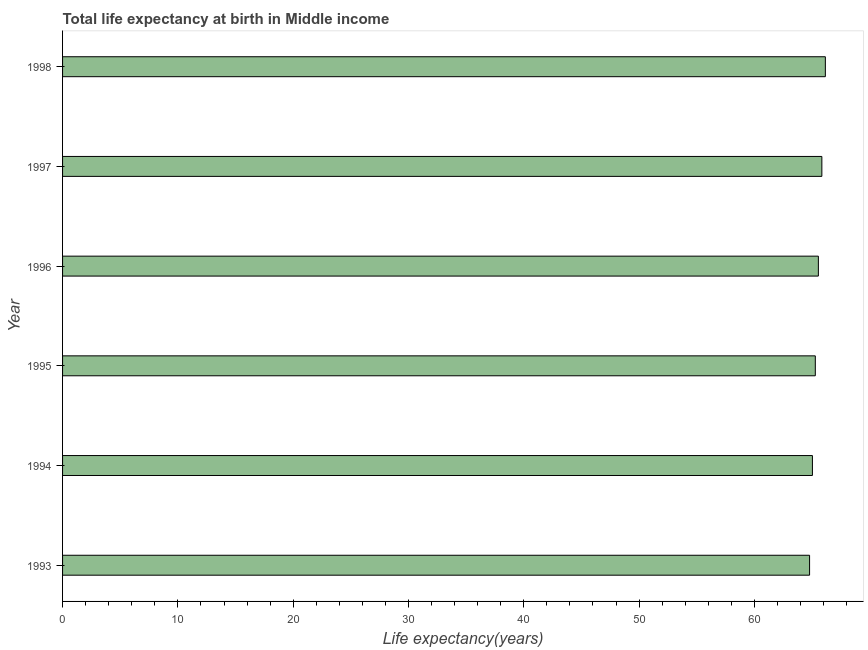Does the graph contain any zero values?
Provide a short and direct response. No. What is the title of the graph?
Provide a short and direct response. Total life expectancy at birth in Middle income. What is the label or title of the X-axis?
Make the answer very short. Life expectancy(years). What is the life expectancy at birth in 1993?
Provide a succinct answer. 64.78. Across all years, what is the maximum life expectancy at birth?
Offer a very short reply. 66.15. Across all years, what is the minimum life expectancy at birth?
Provide a succinct answer. 64.78. What is the sum of the life expectancy at birth?
Your answer should be very brief. 392.64. What is the difference between the life expectancy at birth in 1993 and 1995?
Keep it short and to the point. -0.5. What is the average life expectancy at birth per year?
Provide a succinct answer. 65.44. What is the median life expectancy at birth?
Provide a succinct answer. 65.41. In how many years, is the life expectancy at birth greater than 22 years?
Provide a short and direct response. 6. Do a majority of the years between 1993 and 1995 (inclusive) have life expectancy at birth greater than 20 years?
Your response must be concise. Yes. Is the life expectancy at birth in 1997 less than that in 1998?
Your response must be concise. Yes. Is the difference between the life expectancy at birth in 1994 and 1998 greater than the difference between any two years?
Offer a terse response. No. What is the difference between the highest and the second highest life expectancy at birth?
Offer a terse response. 0.3. What is the difference between the highest and the lowest life expectancy at birth?
Give a very brief answer. 1.37. How many bars are there?
Ensure brevity in your answer.  6. Are all the bars in the graph horizontal?
Provide a short and direct response. Yes. How many years are there in the graph?
Your answer should be compact. 6. What is the difference between two consecutive major ticks on the X-axis?
Provide a short and direct response. 10. What is the Life expectancy(years) of 1993?
Keep it short and to the point. 64.78. What is the Life expectancy(years) in 1994?
Give a very brief answer. 65.03. What is the Life expectancy(years) in 1995?
Provide a short and direct response. 65.28. What is the Life expectancy(years) in 1996?
Your response must be concise. 65.55. What is the Life expectancy(years) of 1997?
Offer a very short reply. 65.85. What is the Life expectancy(years) in 1998?
Your answer should be compact. 66.15. What is the difference between the Life expectancy(years) in 1993 and 1994?
Your answer should be very brief. -0.25. What is the difference between the Life expectancy(years) in 1993 and 1995?
Your response must be concise. -0.5. What is the difference between the Life expectancy(years) in 1993 and 1996?
Your answer should be very brief. -0.76. What is the difference between the Life expectancy(years) in 1993 and 1997?
Ensure brevity in your answer.  -1.07. What is the difference between the Life expectancy(years) in 1993 and 1998?
Keep it short and to the point. -1.37. What is the difference between the Life expectancy(years) in 1994 and 1995?
Provide a succinct answer. -0.25. What is the difference between the Life expectancy(years) in 1994 and 1996?
Your answer should be very brief. -0.52. What is the difference between the Life expectancy(years) in 1994 and 1997?
Your response must be concise. -0.82. What is the difference between the Life expectancy(years) in 1994 and 1998?
Your answer should be very brief. -1.12. What is the difference between the Life expectancy(years) in 1995 and 1996?
Keep it short and to the point. -0.27. What is the difference between the Life expectancy(years) in 1995 and 1997?
Offer a terse response. -0.57. What is the difference between the Life expectancy(years) in 1995 and 1998?
Keep it short and to the point. -0.87. What is the difference between the Life expectancy(years) in 1996 and 1997?
Offer a terse response. -0.3. What is the difference between the Life expectancy(years) in 1996 and 1998?
Your response must be concise. -0.61. What is the difference between the Life expectancy(years) in 1997 and 1998?
Your answer should be compact. -0.3. What is the ratio of the Life expectancy(years) in 1993 to that in 1994?
Your answer should be very brief. 1. What is the ratio of the Life expectancy(years) in 1993 to that in 1996?
Make the answer very short. 0.99. What is the ratio of the Life expectancy(years) in 1993 to that in 1997?
Offer a terse response. 0.98. What is the ratio of the Life expectancy(years) in 1994 to that in 1996?
Your response must be concise. 0.99. What is the ratio of the Life expectancy(years) in 1995 to that in 1996?
Your answer should be very brief. 1. What is the ratio of the Life expectancy(years) in 1996 to that in 1997?
Your answer should be compact. 0.99. 